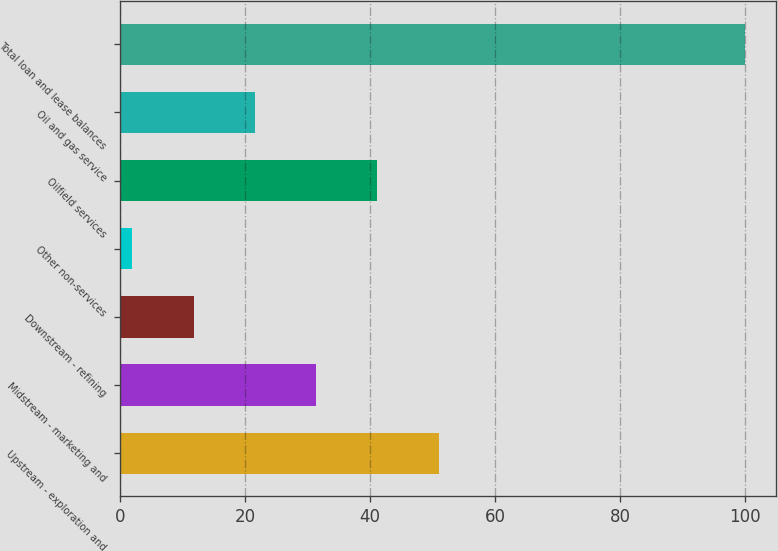Convert chart. <chart><loc_0><loc_0><loc_500><loc_500><bar_chart><fcel>Upstream - exploration and<fcel>Midstream - marketing and<fcel>Downstream - refining<fcel>Other non-services<fcel>Oilfield services<fcel>Oil and gas service<fcel>Total loan and lease balances<nl><fcel>51<fcel>31.4<fcel>11.8<fcel>2<fcel>41.2<fcel>21.6<fcel>100<nl></chart> 